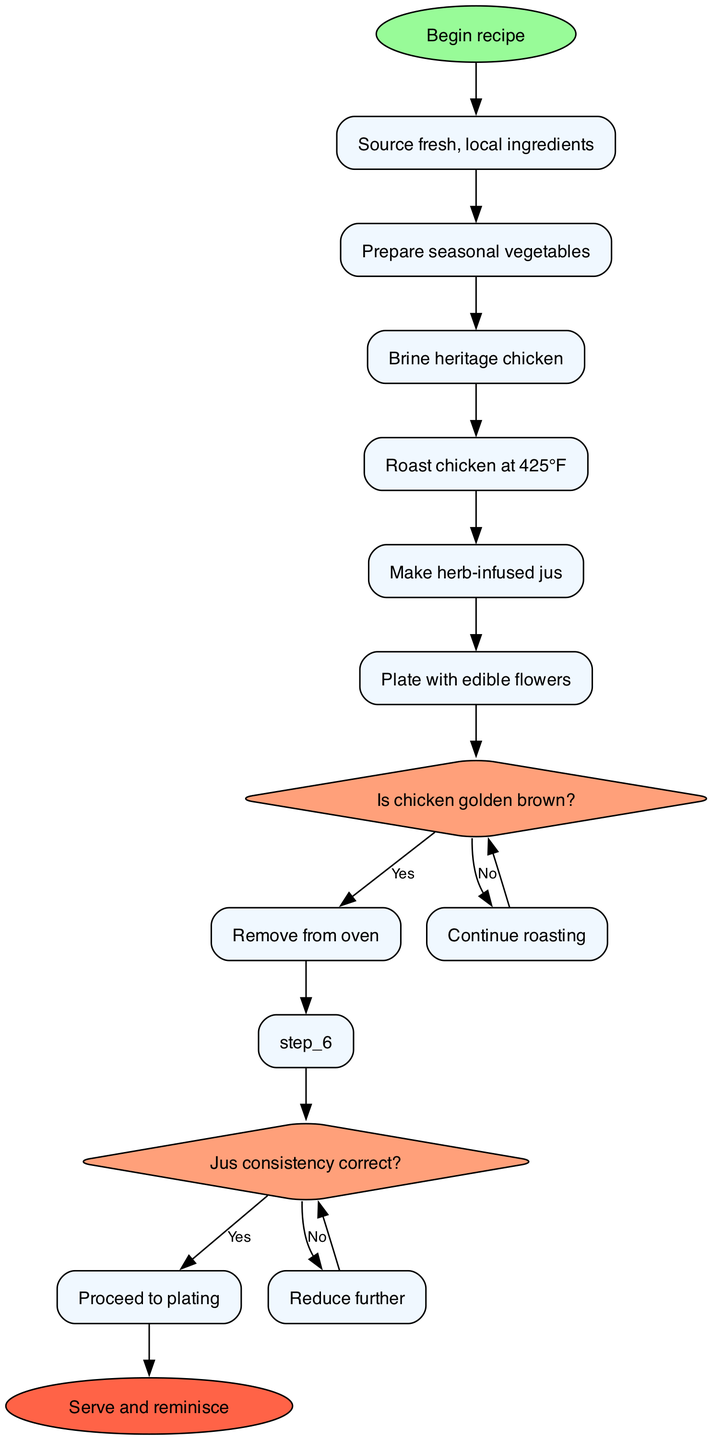What is the starting point of the recipe? The starting point is indicated by the "start" node, which states "Begin recipe."
Answer: Begin recipe How many steps are listed in the recipe? The recipe consists of six distinct steps, as evidenced by the flow from the start node through subsequent steps.
Answer: 6 What is the outcome if the chicken is not golden brown? According to the flowchart, if the chicken is not golden brown, the next action is to "Continue roasting."
Answer: Continue roasting What is the herb-infused sauce referred to in the diagram? It is referred to as "Make herb-infused jus" in the flowchart between the steps of roasting chicken and decision-making about the jus.
Answer: Make herb-infused jus What happens when the jus consistency is correct? If the jus consistency is correct, the next step in the flow after the decision is to "Proceed to plating."
Answer: Proceed to plating What is the final step after all preparations are complete? The final step leads to the end node, which states "Serve and reminisce." This signifies the completion of the recipe.
Answer: Serve and reminisce How does the decision regarding the jus consistency connect to the plating step? If the consistency is correct, it leads directly to the "Proceed to plating" step; if not, it indicates that one must reduce the jus further.
Answer: It leads directly to "Proceed to plating." What is indicated by the node that asks if the chicken is golden brown? This node represents a decision point where one must evaluate the chicken's readiness to assess if it should be removed from the oven or continue roasting.
Answer: A decision point 